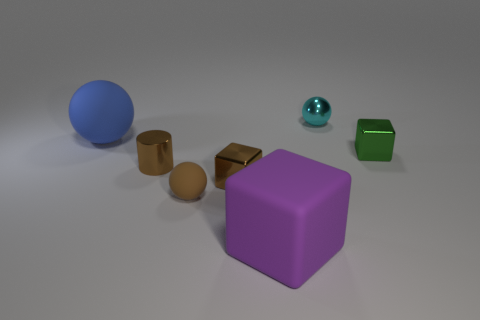There is a tiny shiny sphere; is its color the same as the large thing on the left side of the tiny rubber ball?
Provide a short and direct response. No. Are there any other things that have the same shape as the purple matte thing?
Your answer should be very brief. Yes. What is the color of the matte object in front of the sphere in front of the brown metal cube?
Ensure brevity in your answer.  Purple. What number of small gray spheres are there?
Provide a short and direct response. 0. What number of metallic objects are either large green cylinders or brown things?
Give a very brief answer. 2. How many metallic blocks have the same color as the metal cylinder?
Ensure brevity in your answer.  1. What material is the small sphere that is to the left of the small shiny thing behind the green metal block made of?
Offer a very short reply. Rubber. How big is the blue matte ball?
Your response must be concise. Large. What number of purple cubes have the same size as the blue rubber object?
Make the answer very short. 1. What number of purple things are the same shape as the tiny cyan thing?
Offer a very short reply. 0. 